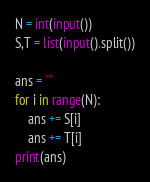<code> <loc_0><loc_0><loc_500><loc_500><_Python_>N = int(input())
S,T = list(input().split())

ans = ""
for i in range(N):
	ans += S[i]
	ans += T[i]
print(ans)
</code> 